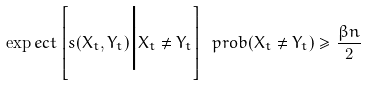Convert formula to latex. <formula><loc_0><loc_0><loc_500><loc_500>\exp e c t \left [ s ( X _ { t } , Y _ { t } ) \Big | X _ { t } \neq Y _ { t } \right ] \ p r o b ( X _ { t } \neq Y _ { t } ) \geq \frac { \beta n } { 2 }</formula> 